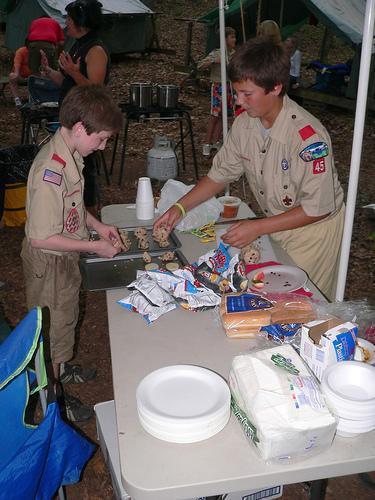How many scouts are baking cookies?
Give a very brief answer. 2. How many people are there?
Give a very brief answer. 3. How many chairs are visible?
Give a very brief answer. 2. How many dining tables are there?
Give a very brief answer. 1. 